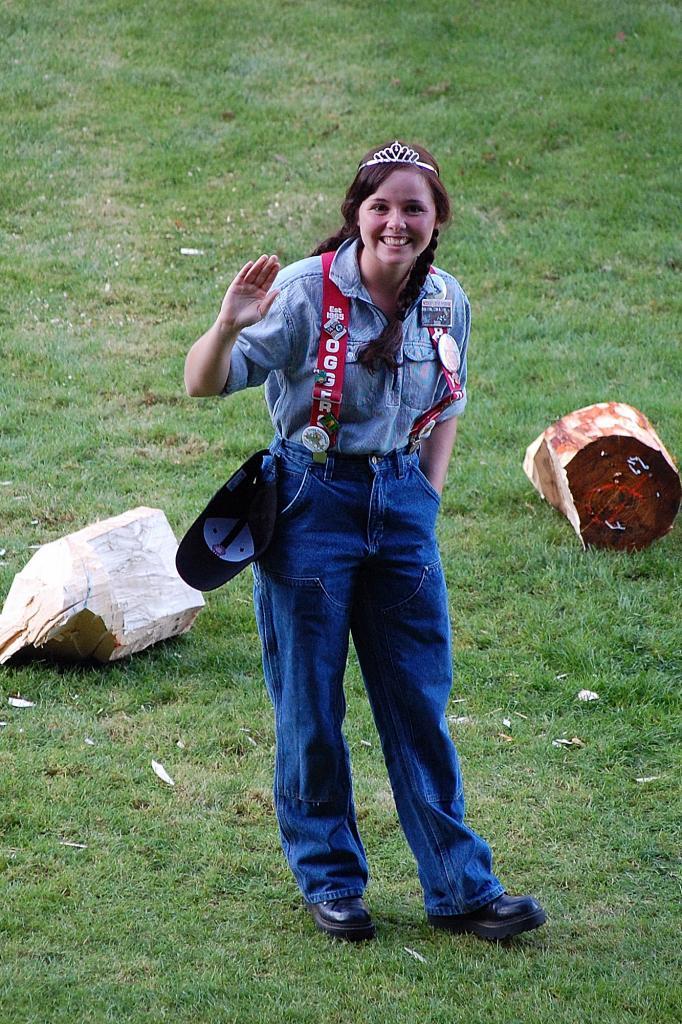Could you give a brief overview of what you see in this image? In this picture there is a woman who is wearing crown, shirt, trouser and shoes. She is standing on the ground, beside her I can see the woods. At the top I can see the green grass. 